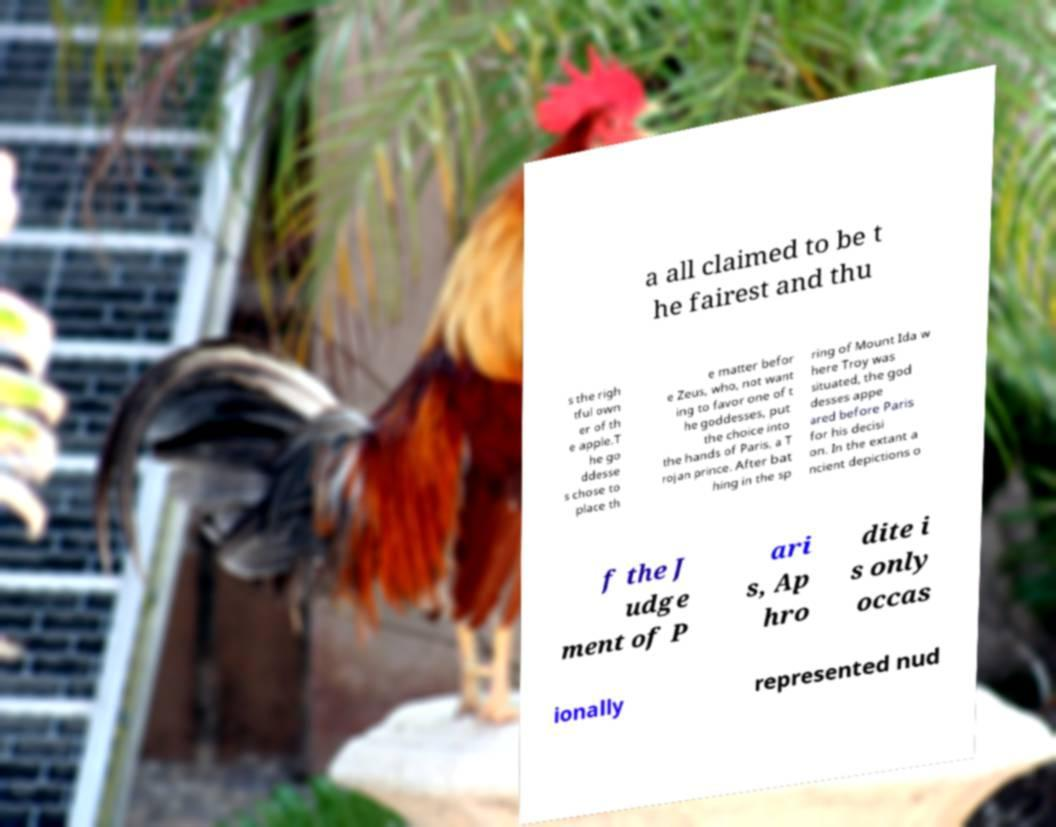For documentation purposes, I need the text within this image transcribed. Could you provide that? a all claimed to be t he fairest and thu s the righ tful own er of th e apple.T he go ddesse s chose to place th e matter befor e Zeus, who, not want ing to favor one of t he goddesses, put the choice into the hands of Paris, a T rojan prince. After bat hing in the sp ring of Mount Ida w here Troy was situated, the god desses appe ared before Paris for his decisi on. In the extant a ncient depictions o f the J udge ment of P ari s, Ap hro dite i s only occas ionally represented nud 